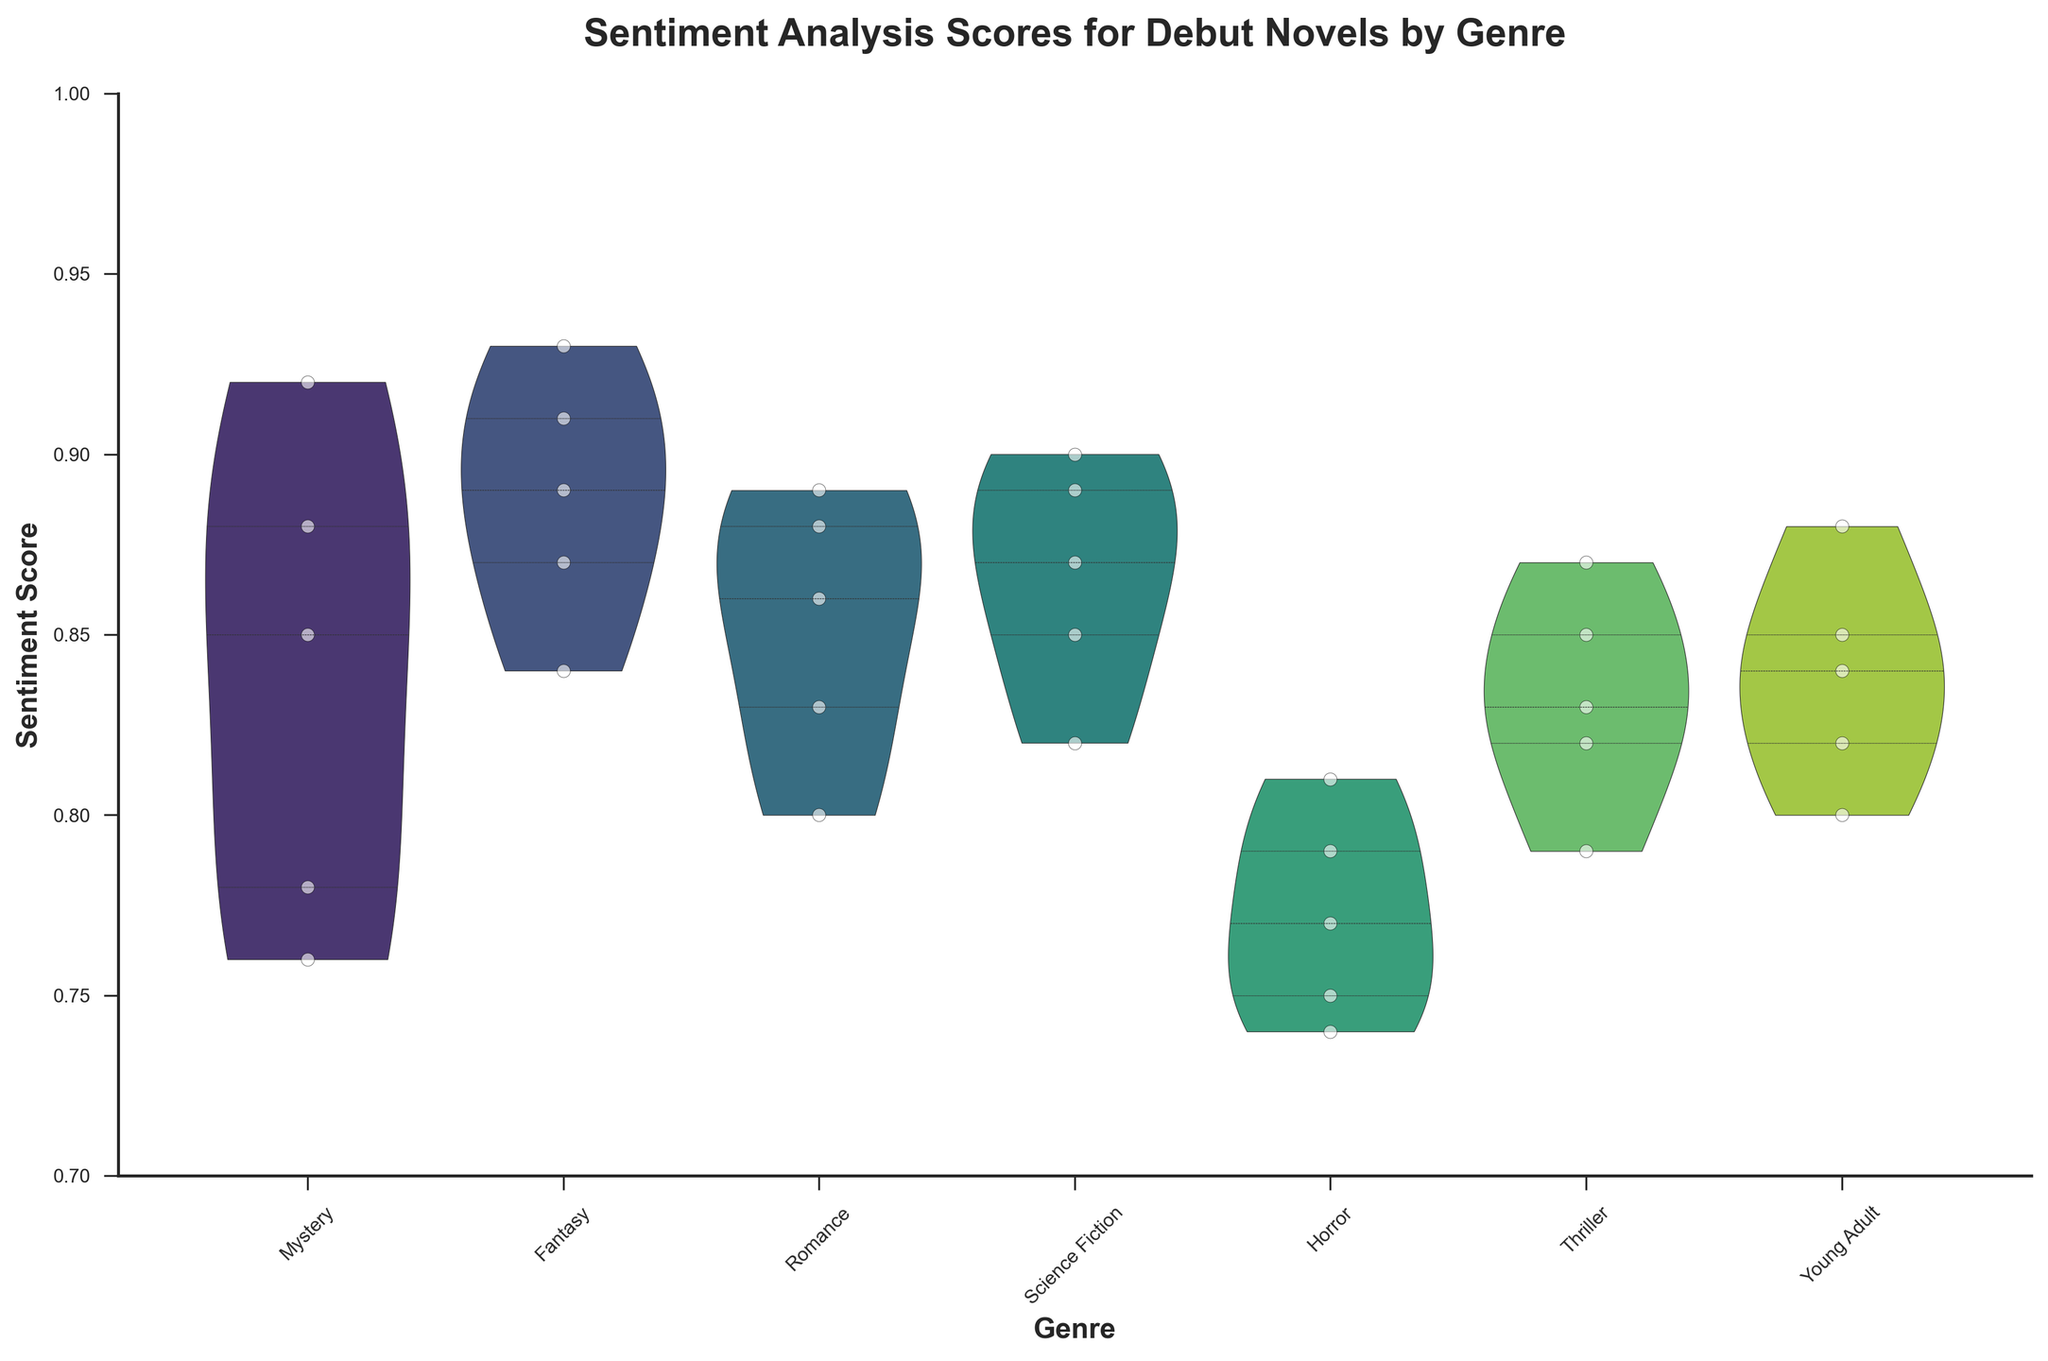What is the title of the figure? The title is generally located at the top of the figure. By looking at the top, we can see "Sentiment Analysis Scores for Debut Novels by Genre".
Answer: Sentiment Analysis Scores for Debut Novels by Genre Which genre has the highest median sentiment score? In a violin plot, the median is usually indicated by a line within the inner quartile marks. By scanning through the lines, we see that Fantasy has the highest median sentiment score.
Answer: Fantasy Which genre has the lowest range of sentiment scores? The range can be determined by looking at the vertical span of each violin. Horror has the shortest vertical span, indicating the lowest range of sentiment scores.
Answer: Horror Which two genres have the most similar ranges of sentiment scores? For each genre, visually compare the vertical spans of the violins. Science Fiction and Thriller have very similar ranges in terms of sentiment scores.
Answer: Science Fiction and Thriller What is the minimum sentiment score for the Horror genre? The lower end of the violin plot for Horror shows the minimum sentiment score. By observing, it's at approximately 0.74.
Answer: 0.74 How do the sentiment score ranges compare between Romance and Young Adult genres? By comparing the vertical spans of the violins, we can see that Romance has a slightly wider range than Young Adult. Romance spans from around 0.8 to 0.89, whereas Young Adult spans from around 0.8 to 0.88.
Answer: Romance has a wider range than Young Adult Which genre has the most dispersed sentiment scores? The dispersion is indicated by the width of the violin. Fantasy, with its wider violin shape in the middle, has the most dispersed sentiment scores.
Answer: Fantasy How many unique genres are represented in the figure? By counting the distinct labels on the x-axis of the violin plot, we find six unique genres: Mystery, Fantasy, Romance, Science Fiction, Horror, and Thriller.
Answer: 6 What is the average sentiment score for the Romance genre? To find the average, sum the sentiment scores of all Romance novels and divide by the number of novels. Calculation: (0.86 + 0.80 + 0.88 + 0.83 + 0.89)/5 = 4.26/5 = 0.852
Answer: 0.852 